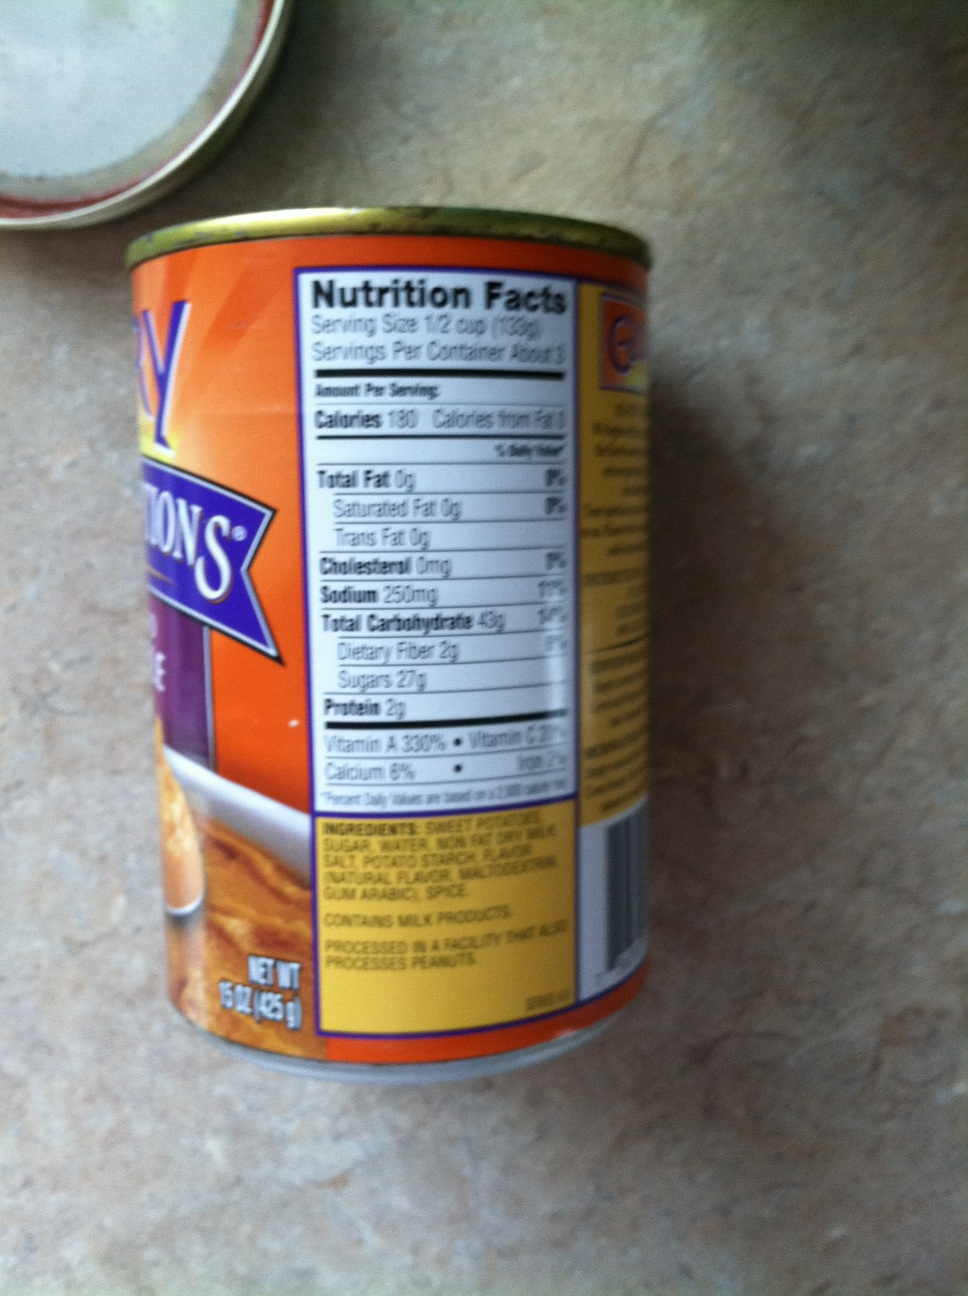Can you describe a short scenario where this product might be used? This tin of sweet potatoes might be used in a quick weekday dinner. Imagine coming home after a long day and wanting to prepare a healthy meal for your family without spending hours in the kitchen. You could quickly prepare a sweet potato mash by heating and mashing the sweet potatoes from the can, adding a touch of butter and cinnamon for flavor—a simple yet nutritious side dish to accompany grilled chicken and steamed vegetables. 